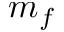<formula> <loc_0><loc_0><loc_500><loc_500>m _ { f }</formula> 